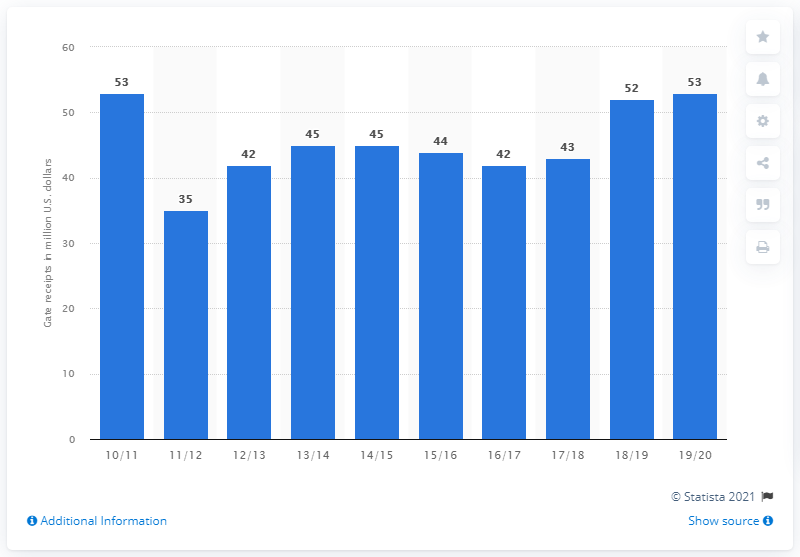Specify some key components in this picture. The Dallas Mavericks' gate receipts in the 2019/20 season were $53 million. 